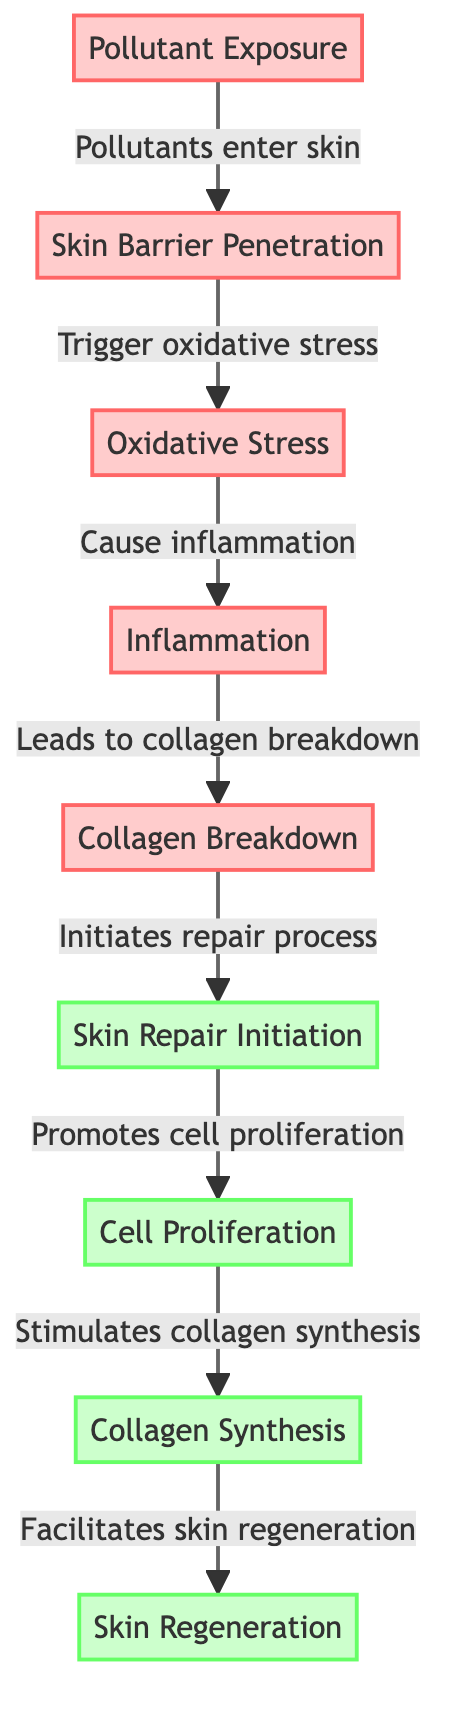What is the first stage of skin damage? The first stage in the flow of the diagram is "Pollutant Exposure", indicating that this is the initiating event in the skin damage process.
Answer: Pollutant Exposure How many distinct stages are involved in the skin repair process? The diagram shows four stages involved in the skin repair process: Skin Repair Initiation, Cell Proliferation, Collagen Synthesis, and Skin Regeneration. Counting these four stages gives us the total.
Answer: 4 What stage comes immediately after inflammation? Following the stage of inflammation in the diagram, the next stage is "Collagen Breakdown", which occurs as a result.
Answer: Collagen Breakdown Which process leads to skin regeneration? The diagram delineates that "Collagen Synthesis" promotes the next step, which is "Skin Regeneration". Therefore, collagen synthesis is identified as the process leading to regeneration.
Answer: Collagen Synthesis What triggers oxidative stress in the skin? The diagram indicates that "Skin Barrier Penetration" is responsible for triggering oxidative stress as pollutants enter the skin.
Answer: Pollutants enter skin What are the stages categorized as repair processes? Looking at the diagram, the stages that are categorized as repair processes are: Skin Repair Initiation, Cell Proliferation, Collagen Synthesis, and Skin Regeneration—all of which restore the skin.
Answer: Skin Repair Initiation, Cell Proliferation, Collagen Synthesis, Skin Regeneration What is the consequence of oxidative stress in the skin? According to the diagram, oxidative stress leads to "Inflammation", establishing a direct link between these two phenomena.
Answer: Inflammation How does collagen breakdown affect skin repair? The diagram illustrates that collagen breakdown initiates the repair process, signifying that it is a precursor action for repairing the skin.
Answer: Initiates repair process What color represents the stages of skin damage in the diagram? The stages of skin damage, represented in the diagram, are colored in light red (denoting damage), while repair stages are indicated in light green.
Answer: Light red 